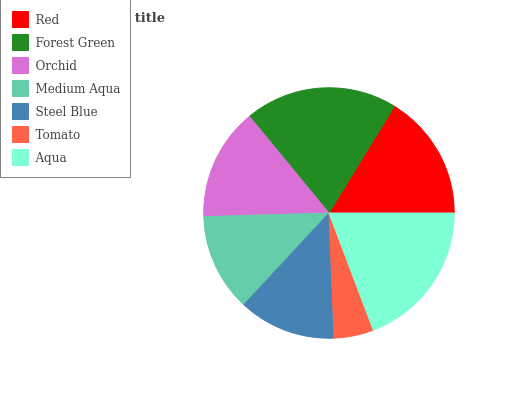Is Tomato the minimum?
Answer yes or no. Yes. Is Forest Green the maximum?
Answer yes or no. Yes. Is Orchid the minimum?
Answer yes or no. No. Is Orchid the maximum?
Answer yes or no. No. Is Forest Green greater than Orchid?
Answer yes or no. Yes. Is Orchid less than Forest Green?
Answer yes or no. Yes. Is Orchid greater than Forest Green?
Answer yes or no. No. Is Forest Green less than Orchid?
Answer yes or no. No. Is Orchid the high median?
Answer yes or no. Yes. Is Orchid the low median?
Answer yes or no. Yes. Is Medium Aqua the high median?
Answer yes or no. No. Is Steel Blue the low median?
Answer yes or no. No. 